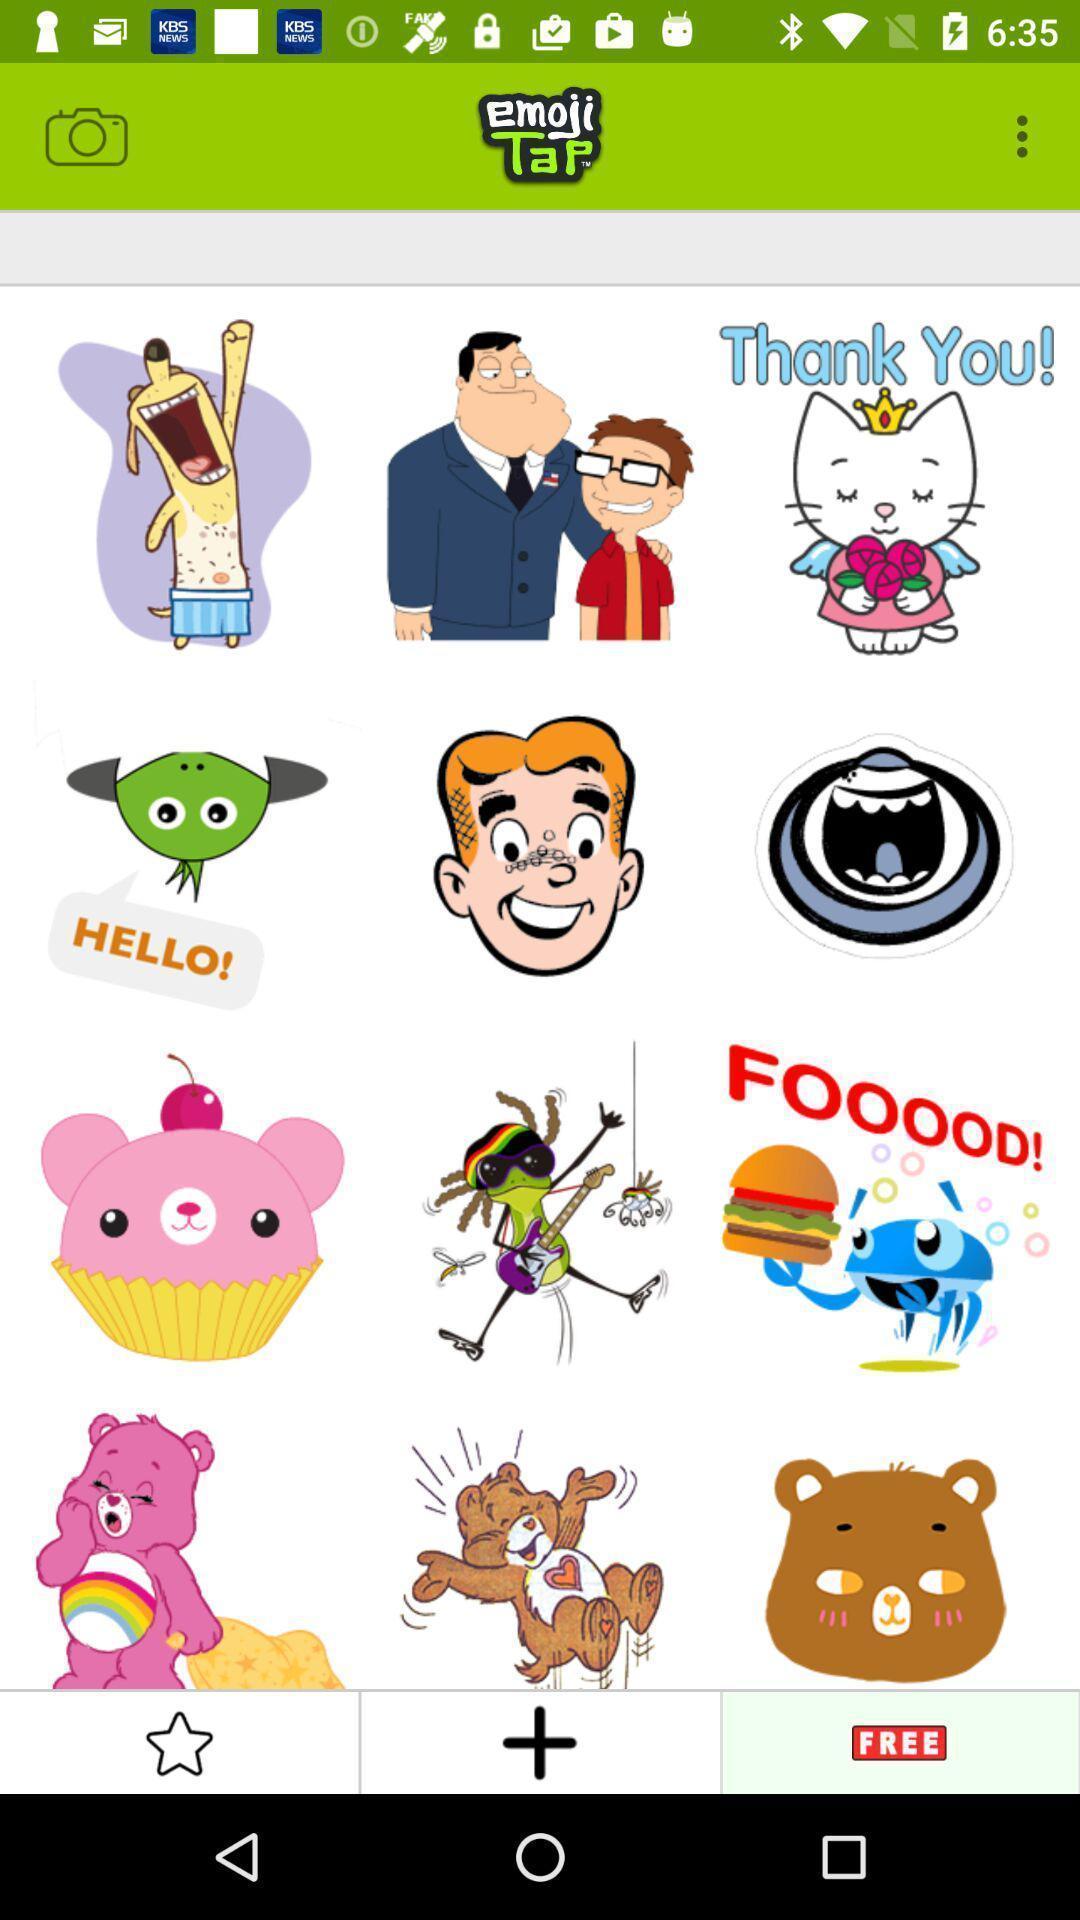Summarize the information in this screenshot. Screen showing the emojis. 